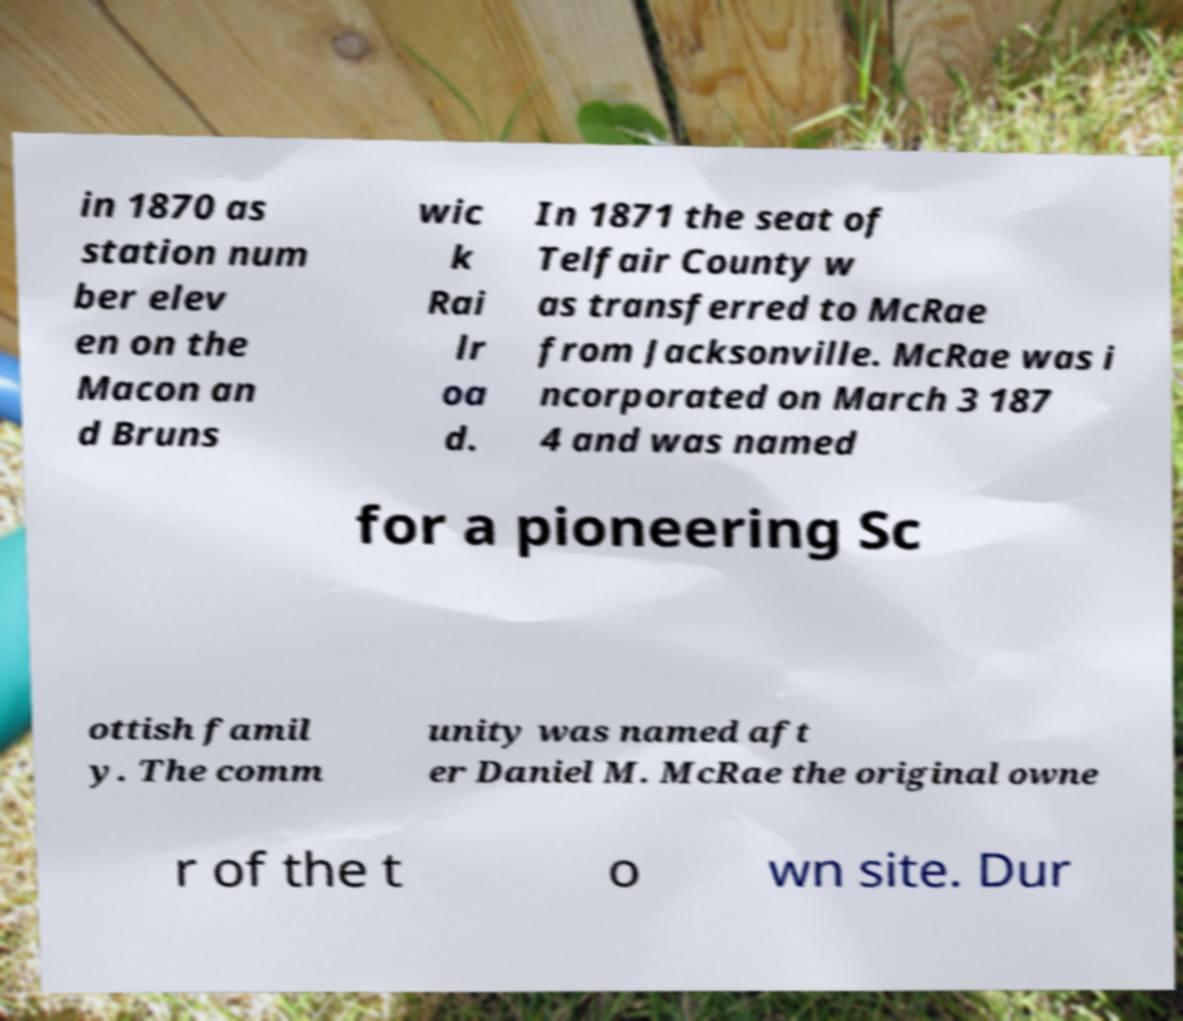Could you assist in decoding the text presented in this image and type it out clearly? in 1870 as station num ber elev en on the Macon an d Bruns wic k Rai lr oa d. In 1871 the seat of Telfair County w as transferred to McRae from Jacksonville. McRae was i ncorporated on March 3 187 4 and was named for a pioneering Sc ottish famil y. The comm unity was named aft er Daniel M. McRae the original owne r of the t o wn site. Dur 